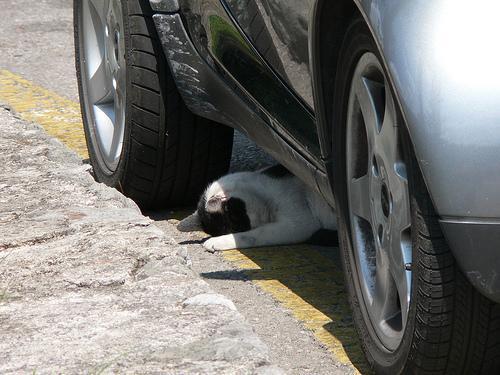How many cats are there?
Give a very brief answer. 1. 